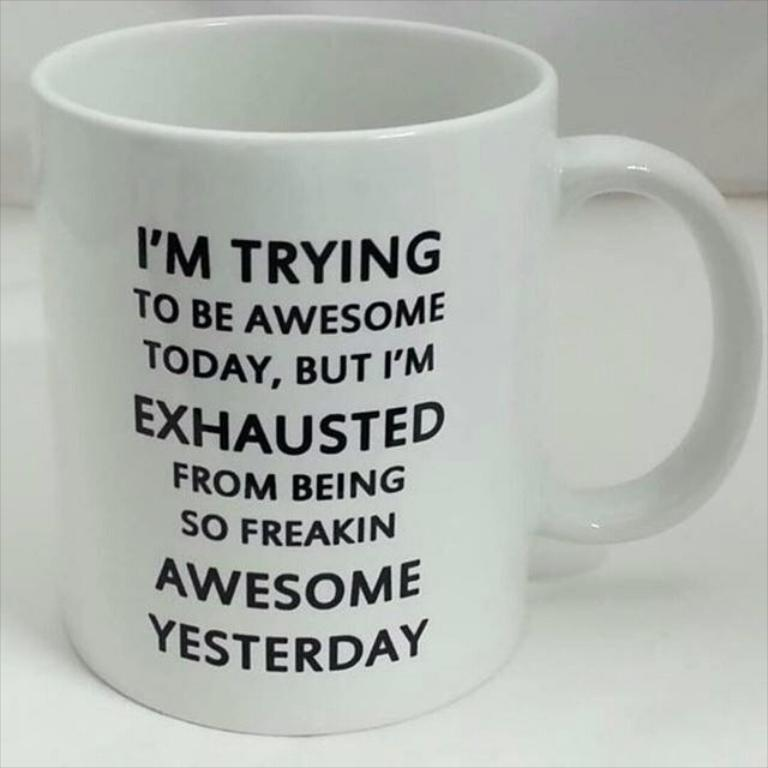<image>
Summarize the visual content of the image. A white coffee cup that says " I'm trying to be awesome today, but I'm exhausted from being so freaking awesome yesterday." 